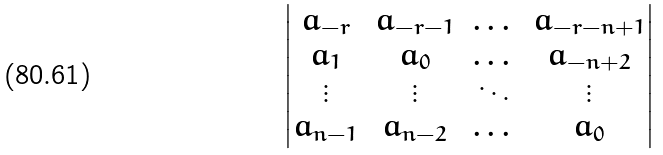<formula> <loc_0><loc_0><loc_500><loc_500>\begin{vmatrix} a _ { - r } & a _ { - r - 1 } & \dots & a _ { - r - n + 1 } \\ a _ { 1 } & a _ { 0 } & \dots & a _ { - n + 2 } \\ \vdots & \vdots & \ddots & \vdots \\ a _ { n - 1 } & a _ { n - 2 } & \dots & a _ { 0 } \end{vmatrix}</formula> 